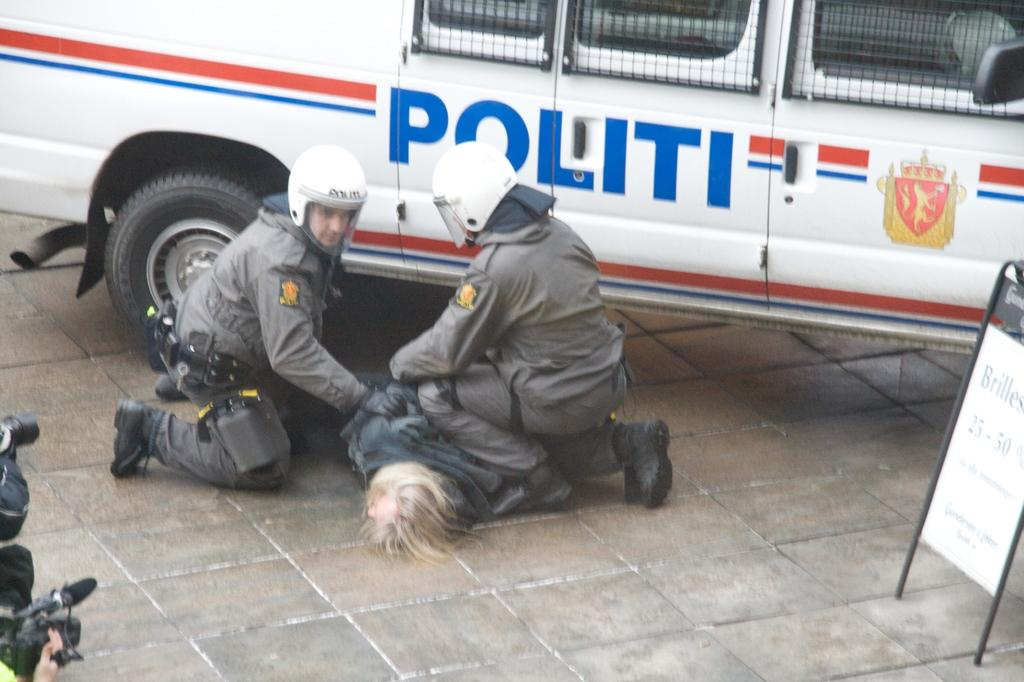<image>
Present a compact description of the photo's key features. Two men have another man on the ground next to a Politi van. 